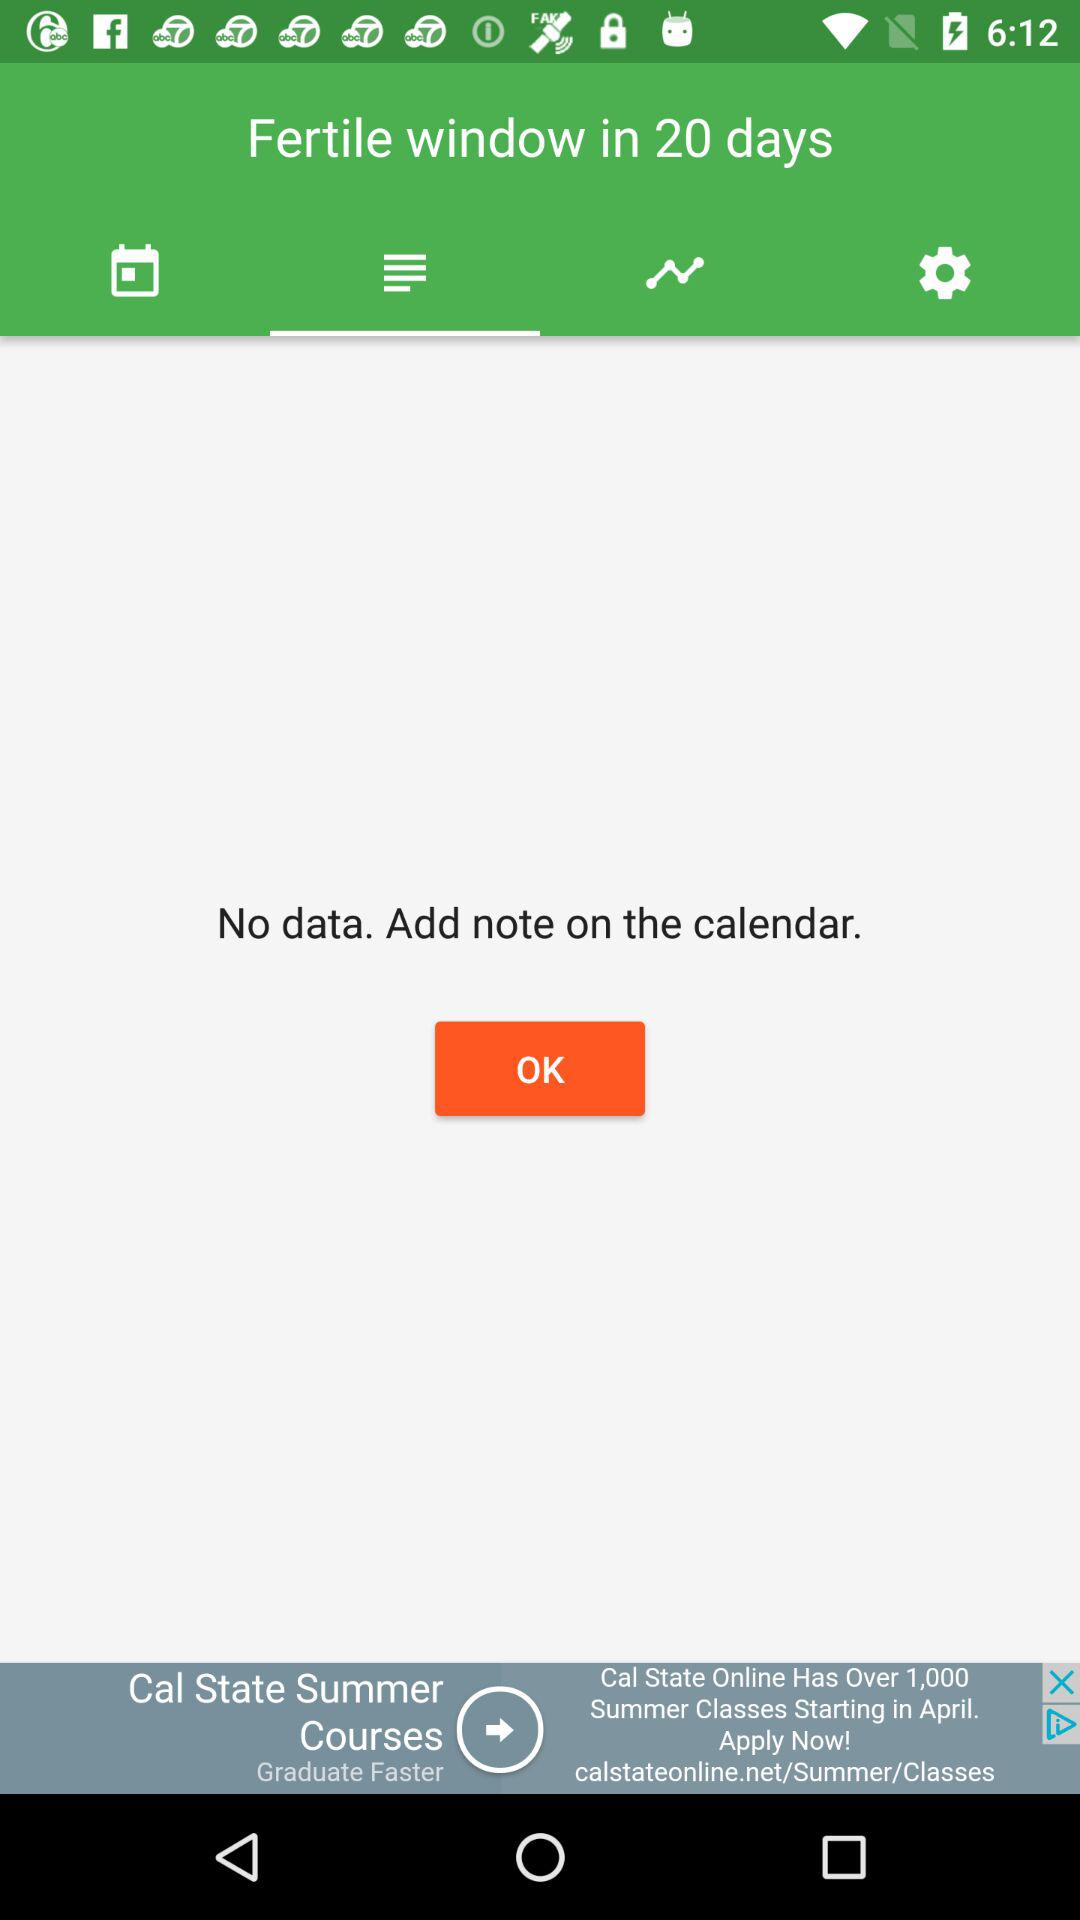When is the fertile window? The fertile window is in 20 days. 